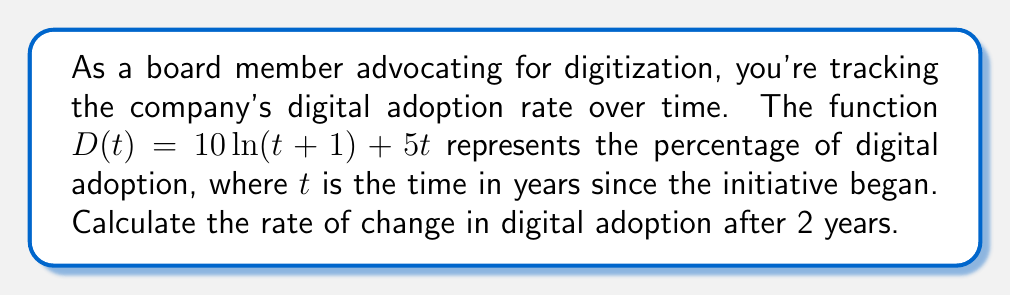Show me your answer to this math problem. To solve this problem, we need to find the derivative of the given function and evaluate it at $t=2$. Let's break it down step-by-step:

1. Given function: $D(t) = 10\ln(t+1) + 5t$

2. To find the rate of change, we need to calculate $D'(t)$:
   
   $D'(t) = \frac{d}{dt}[10\ln(t+1) + 5t]$

3. Using the chain rule for the natural logarithm term and the power rule for the linear term:
   
   $D'(t) = 10 \cdot \frac{1}{t+1} \cdot \frac{d}{dt}(t+1) + 5 \cdot \frac{d}{dt}(t)$

4. Simplify:
   
   $D'(t) = \frac{10}{t+1} + 5$

5. Now, we need to evaluate $D'(t)$ at $t=2$:
   
   $D'(2) = \frac{10}{2+1} + 5$
   
   $D'(2) = \frac{10}{3} + 5$
   
   $D'(2) = \frac{10}{3} + \frac{15}{3}$
   
   $D'(2) = \frac{25}{3}$

The rate of change after 2 years is $\frac{25}{3}$ percent per year.
Answer: $\frac{25}{3}$ percent per year 